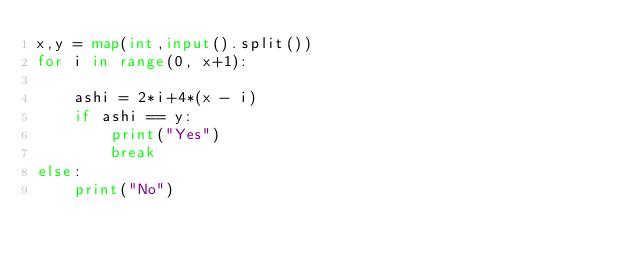<code> <loc_0><loc_0><loc_500><loc_500><_Python_>x,y = map(int,input().split())
for i in range(0, x+1):

    ashi = 2*i+4*(x - i)
    if ashi == y:
        print("Yes")
        break
else:
    print("No")</code> 